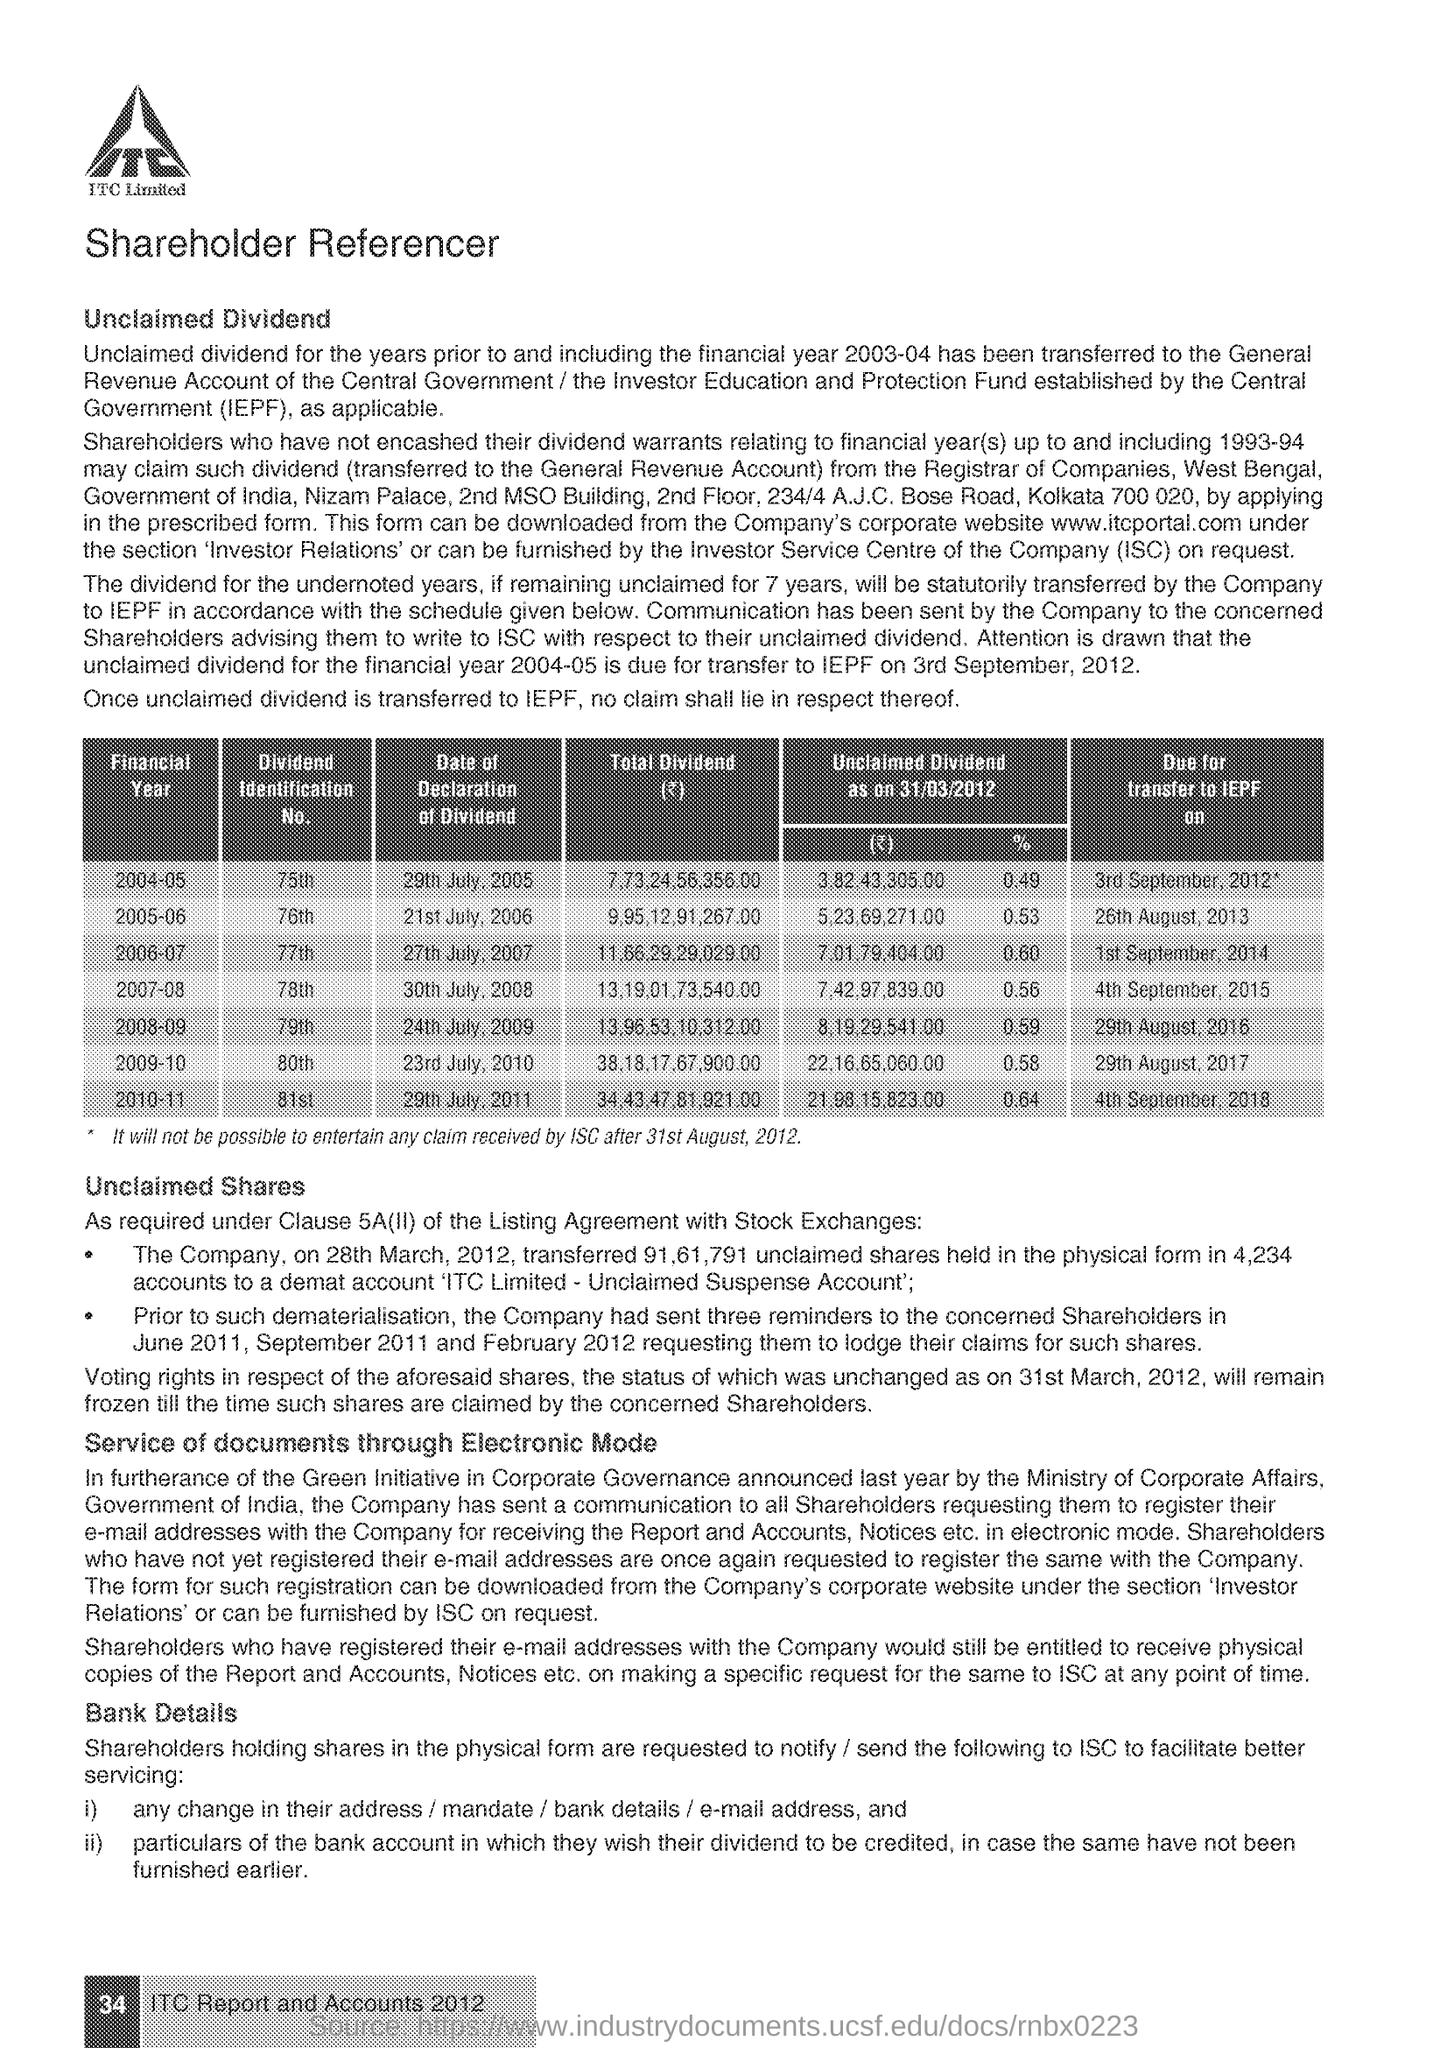Give some essential details in this illustration. The full form of IEPF is Investor Education and Protection Fund, which is a government initiative aimed at promoting investor awareness and safeguarding their interests. The fullform of ISC is Investor Service Centre. ITC Limited is the name of the company. 